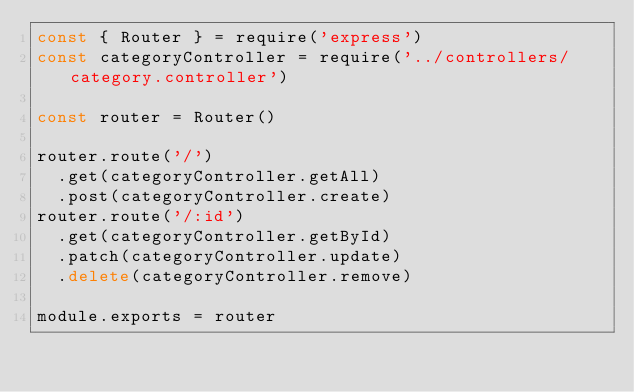Convert code to text. <code><loc_0><loc_0><loc_500><loc_500><_JavaScript_>const { Router } = require('express')
const categoryController = require('../controllers/category.controller')

const router = Router()

router.route('/')
  .get(categoryController.getAll)
  .post(categoryController.create)
router.route('/:id')
  .get(categoryController.getById)
  .patch(categoryController.update)
  .delete(categoryController.remove)

module.exports = router
</code> 